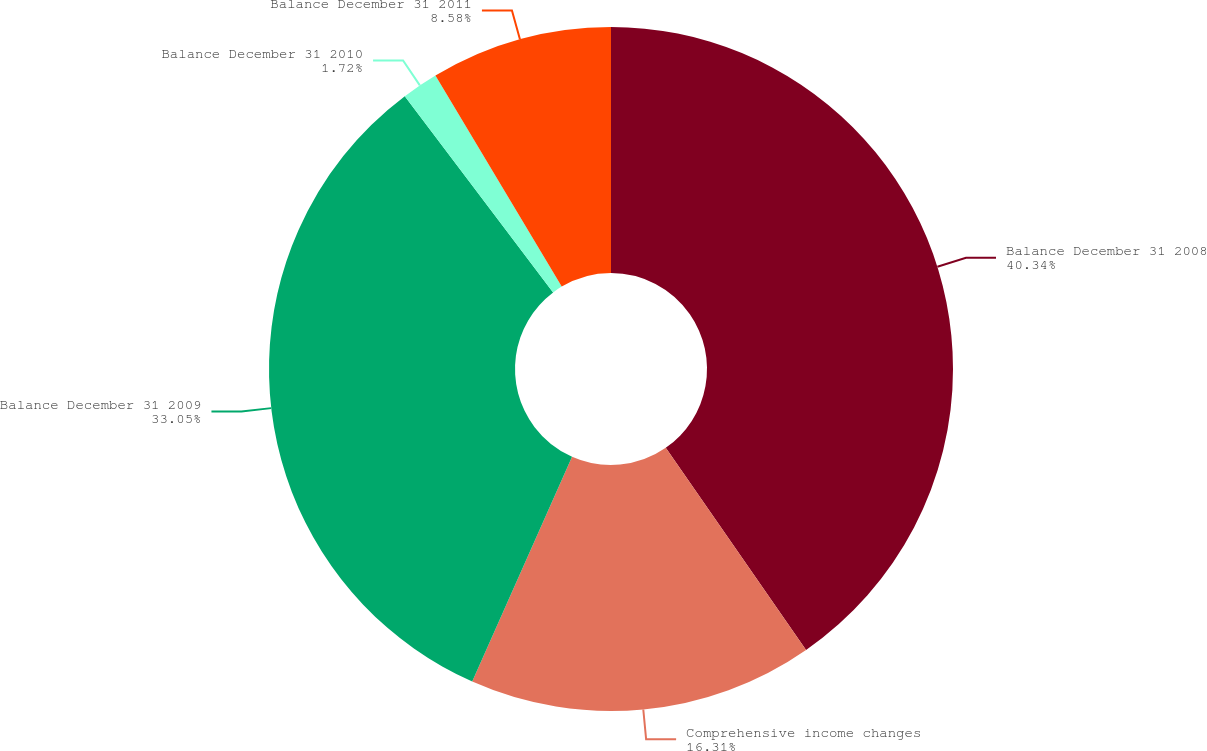Convert chart. <chart><loc_0><loc_0><loc_500><loc_500><pie_chart><fcel>Balance December 31 2008<fcel>Comprehensive income changes<fcel>Balance December 31 2009<fcel>Balance December 31 2010<fcel>Balance December 31 2011<nl><fcel>40.34%<fcel>16.31%<fcel>33.05%<fcel>1.72%<fcel>8.58%<nl></chart> 